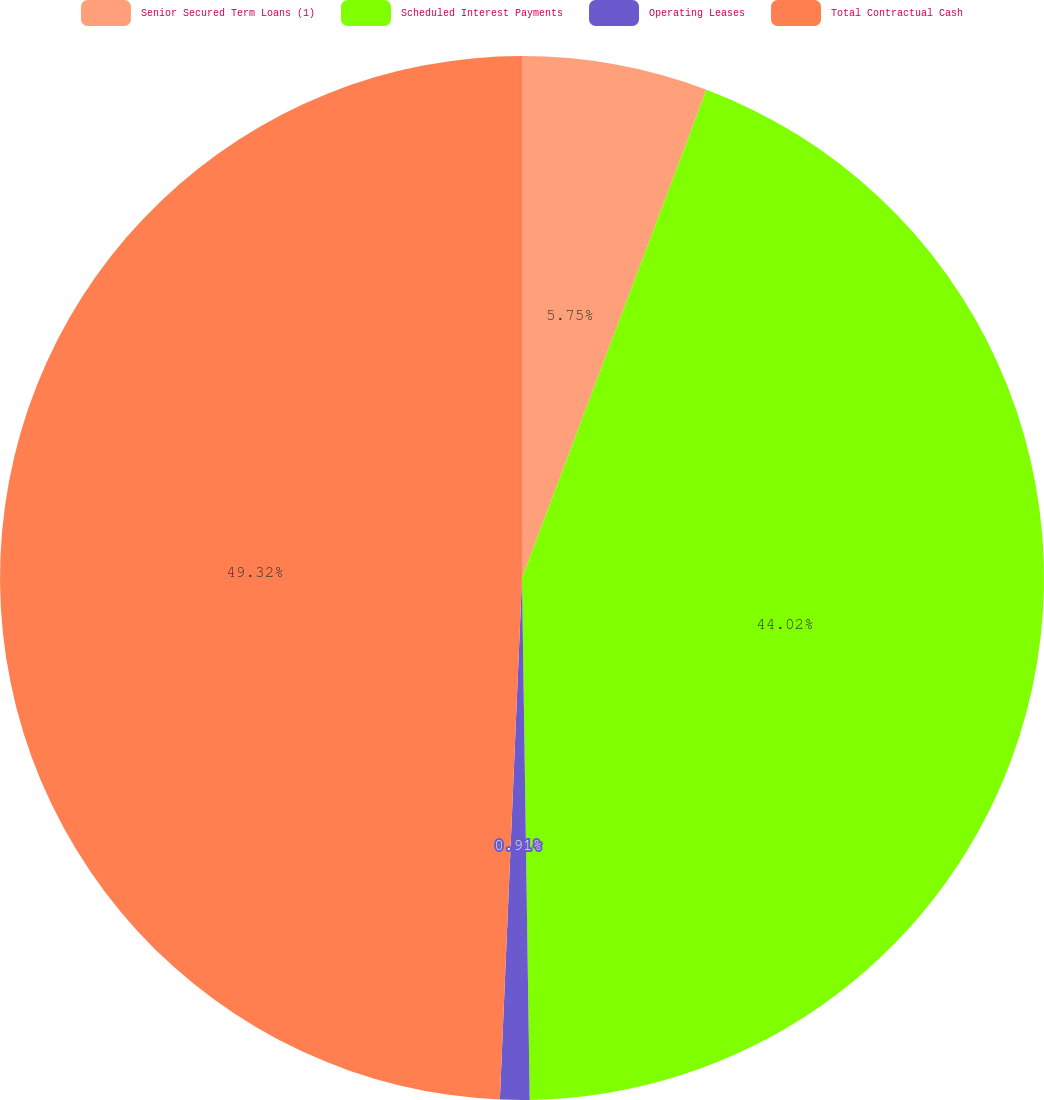Convert chart to OTSL. <chart><loc_0><loc_0><loc_500><loc_500><pie_chart><fcel>Senior Secured Term Loans (1)<fcel>Scheduled Interest Payments<fcel>Operating Leases<fcel>Total Contractual Cash<nl><fcel>5.75%<fcel>44.02%<fcel>0.91%<fcel>49.33%<nl></chart> 